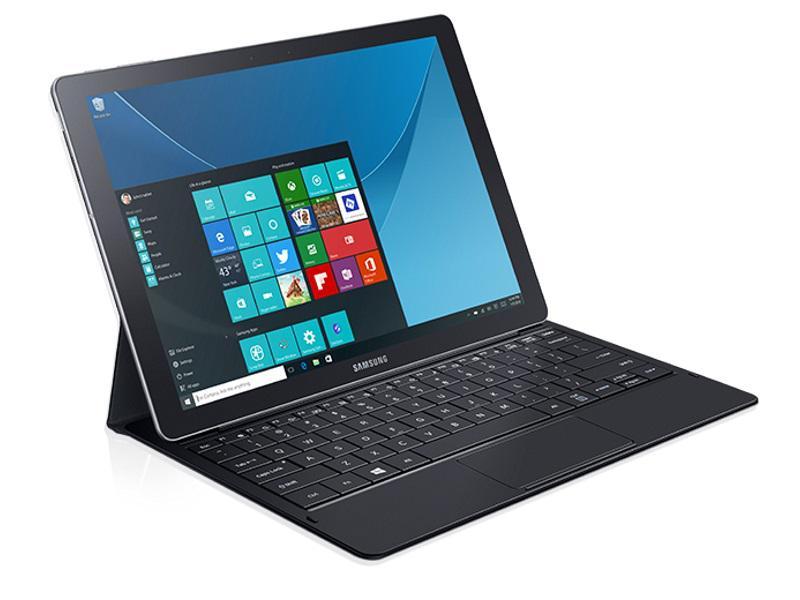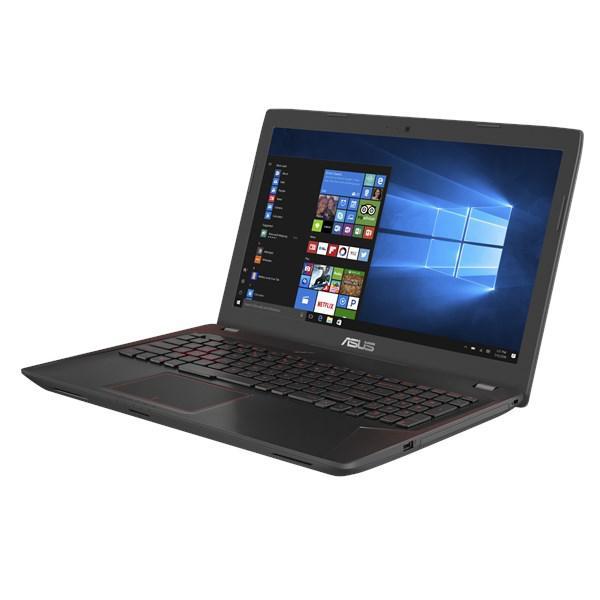The first image is the image on the left, the second image is the image on the right. Given the left and right images, does the statement "Each image shows one opened laptop angled so the screen faces rightward." hold true? Answer yes or no. No. The first image is the image on the left, the second image is the image on the right. Evaluate the accuracy of this statement regarding the images: "Both of the laptops are facing in the same direction.". Is it true? Answer yes or no. No. 